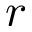Convert formula to latex. <formula><loc_0><loc_0><loc_500><loc_500>r</formula> 